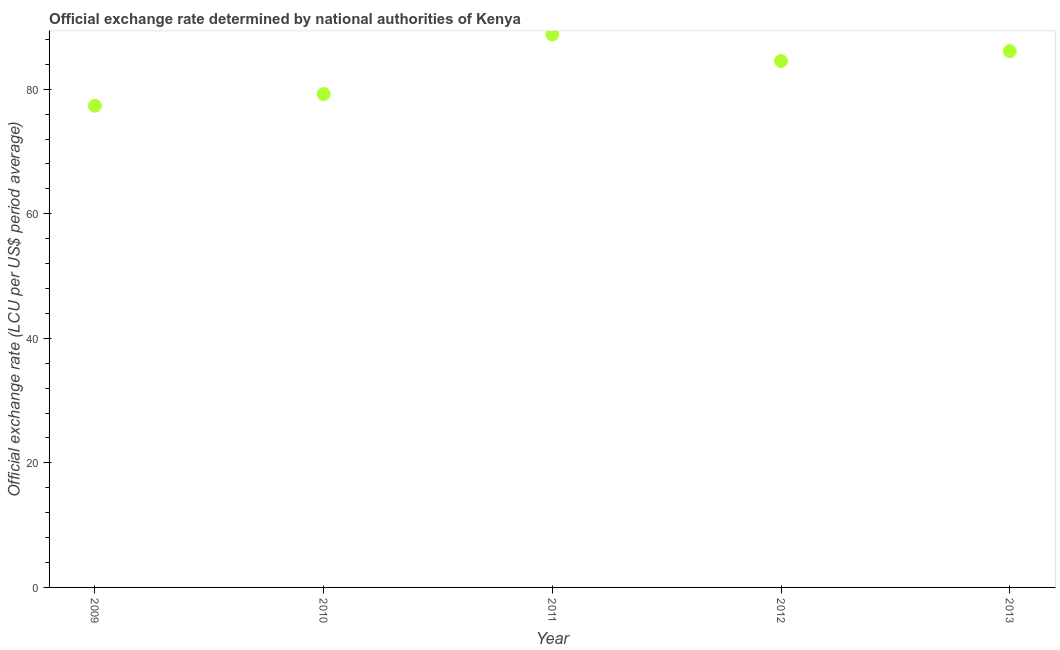What is the official exchange rate in 2013?
Keep it short and to the point. 86.12. Across all years, what is the maximum official exchange rate?
Your answer should be very brief. 88.81. Across all years, what is the minimum official exchange rate?
Ensure brevity in your answer.  77.35. In which year was the official exchange rate minimum?
Offer a very short reply. 2009. What is the sum of the official exchange rate?
Offer a very short reply. 416.05. What is the difference between the official exchange rate in 2011 and 2013?
Provide a short and direct response. 2.69. What is the average official exchange rate per year?
Your response must be concise. 83.21. What is the median official exchange rate?
Keep it short and to the point. 84.53. In how many years, is the official exchange rate greater than 48 ?
Make the answer very short. 5. Do a majority of the years between 2009 and 2012 (inclusive) have official exchange rate greater than 36 ?
Give a very brief answer. Yes. What is the ratio of the official exchange rate in 2012 to that in 2013?
Your answer should be very brief. 0.98. What is the difference between the highest and the second highest official exchange rate?
Give a very brief answer. 2.69. Is the sum of the official exchange rate in 2009 and 2010 greater than the maximum official exchange rate across all years?
Your answer should be compact. Yes. What is the difference between the highest and the lowest official exchange rate?
Provide a short and direct response. 11.46. How many dotlines are there?
Ensure brevity in your answer.  1. How many years are there in the graph?
Your response must be concise. 5. Does the graph contain any zero values?
Ensure brevity in your answer.  No. What is the title of the graph?
Offer a very short reply. Official exchange rate determined by national authorities of Kenya. What is the label or title of the Y-axis?
Provide a succinct answer. Official exchange rate (LCU per US$ period average). What is the Official exchange rate (LCU per US$ period average) in 2009?
Give a very brief answer. 77.35. What is the Official exchange rate (LCU per US$ period average) in 2010?
Offer a terse response. 79.23. What is the Official exchange rate (LCU per US$ period average) in 2011?
Keep it short and to the point. 88.81. What is the Official exchange rate (LCU per US$ period average) in 2012?
Offer a terse response. 84.53. What is the Official exchange rate (LCU per US$ period average) in 2013?
Ensure brevity in your answer.  86.12. What is the difference between the Official exchange rate (LCU per US$ period average) in 2009 and 2010?
Your response must be concise. -1.88. What is the difference between the Official exchange rate (LCU per US$ period average) in 2009 and 2011?
Make the answer very short. -11.46. What is the difference between the Official exchange rate (LCU per US$ period average) in 2009 and 2012?
Offer a very short reply. -7.18. What is the difference between the Official exchange rate (LCU per US$ period average) in 2009 and 2013?
Ensure brevity in your answer.  -8.77. What is the difference between the Official exchange rate (LCU per US$ period average) in 2010 and 2011?
Offer a very short reply. -9.58. What is the difference between the Official exchange rate (LCU per US$ period average) in 2010 and 2012?
Offer a very short reply. -5.3. What is the difference between the Official exchange rate (LCU per US$ period average) in 2010 and 2013?
Keep it short and to the point. -6.89. What is the difference between the Official exchange rate (LCU per US$ period average) in 2011 and 2012?
Offer a terse response. 4.28. What is the difference between the Official exchange rate (LCU per US$ period average) in 2011 and 2013?
Offer a very short reply. 2.69. What is the difference between the Official exchange rate (LCU per US$ period average) in 2012 and 2013?
Your response must be concise. -1.59. What is the ratio of the Official exchange rate (LCU per US$ period average) in 2009 to that in 2011?
Offer a terse response. 0.87. What is the ratio of the Official exchange rate (LCU per US$ period average) in 2009 to that in 2012?
Offer a very short reply. 0.92. What is the ratio of the Official exchange rate (LCU per US$ period average) in 2009 to that in 2013?
Offer a terse response. 0.9. What is the ratio of the Official exchange rate (LCU per US$ period average) in 2010 to that in 2011?
Provide a succinct answer. 0.89. What is the ratio of the Official exchange rate (LCU per US$ period average) in 2010 to that in 2012?
Provide a succinct answer. 0.94. What is the ratio of the Official exchange rate (LCU per US$ period average) in 2010 to that in 2013?
Your response must be concise. 0.92. What is the ratio of the Official exchange rate (LCU per US$ period average) in 2011 to that in 2012?
Offer a very short reply. 1.05. What is the ratio of the Official exchange rate (LCU per US$ period average) in 2011 to that in 2013?
Provide a succinct answer. 1.03. What is the ratio of the Official exchange rate (LCU per US$ period average) in 2012 to that in 2013?
Offer a terse response. 0.98. 